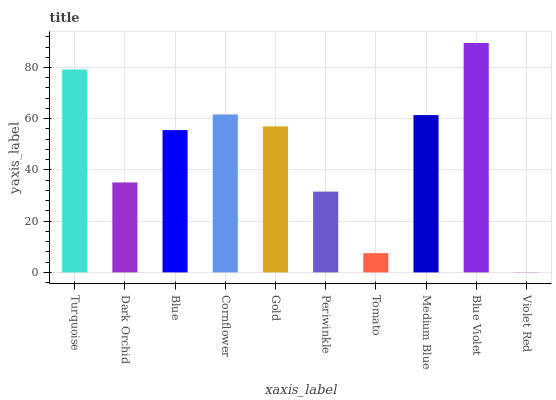Is Violet Red the minimum?
Answer yes or no. Yes. Is Blue Violet the maximum?
Answer yes or no. Yes. Is Dark Orchid the minimum?
Answer yes or no. No. Is Dark Orchid the maximum?
Answer yes or no. No. Is Turquoise greater than Dark Orchid?
Answer yes or no. Yes. Is Dark Orchid less than Turquoise?
Answer yes or no. Yes. Is Dark Orchid greater than Turquoise?
Answer yes or no. No. Is Turquoise less than Dark Orchid?
Answer yes or no. No. Is Gold the high median?
Answer yes or no. Yes. Is Blue the low median?
Answer yes or no. Yes. Is Dark Orchid the high median?
Answer yes or no. No. Is Turquoise the low median?
Answer yes or no. No. 